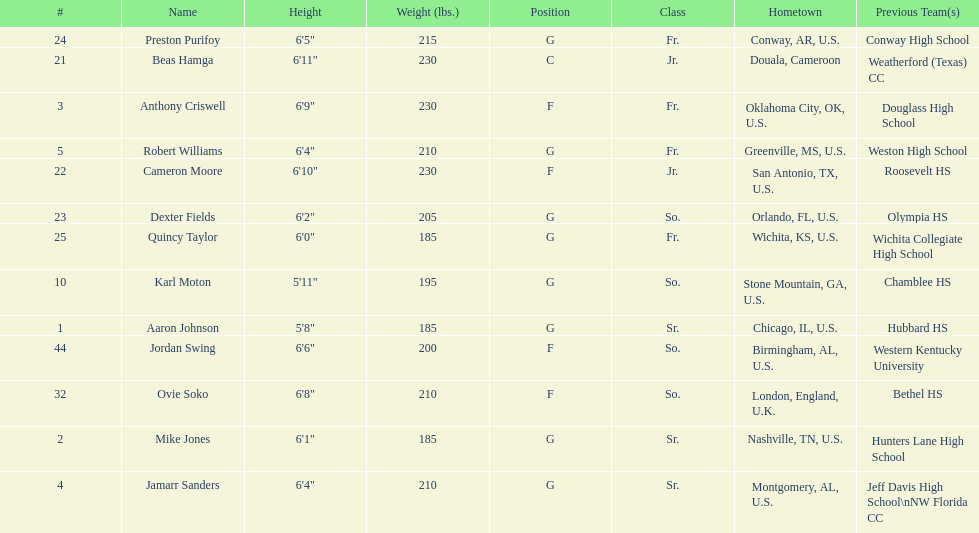Other than soko, tell me a player who is not from the us. Beas Hamga. 